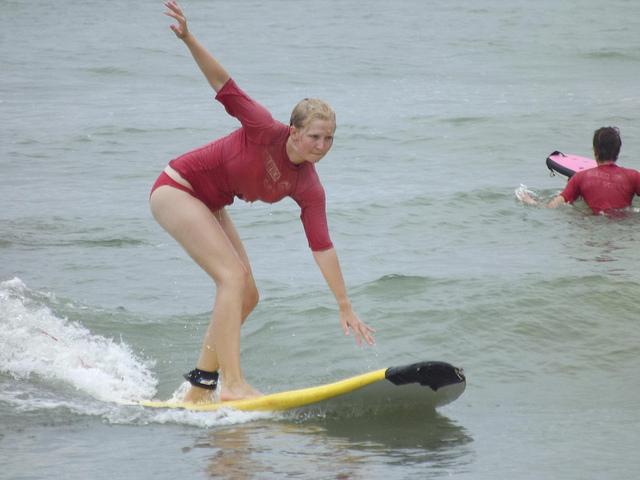Are the people in the photo wearing tops of the same color?
Be succinct. Yes. Is the women wearing a bikini?
Keep it brief. No. Is the surfboard yellow or blue?
Quick response, please. Yellow. Are all the people shown in the image surfing?
Keep it brief. Yes. Which foot has a strap on?
Give a very brief answer. Left. What is the woman doing?
Write a very short answer. Surfing. 